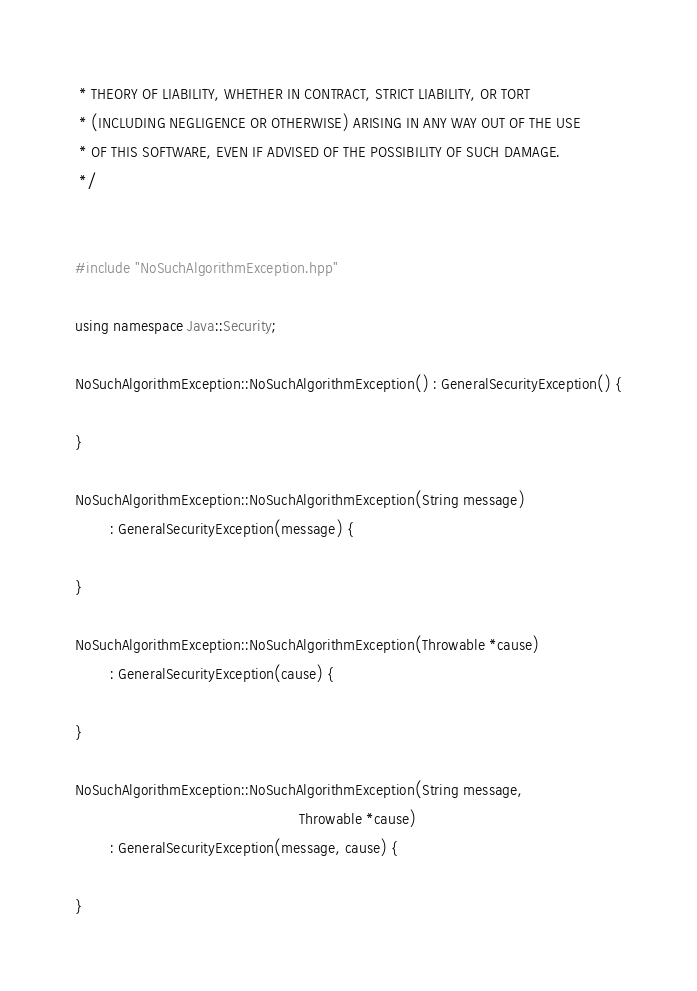Convert code to text. <code><loc_0><loc_0><loc_500><loc_500><_C++_> * THEORY OF LIABILITY, WHETHER IN CONTRACT, STRICT LIABILITY, OR TORT
 * (INCLUDING NEGLIGENCE OR OTHERWISE) ARISING IN ANY WAY OUT OF THE USE
 * OF THIS SOFTWARE, EVEN IF ADVISED OF THE POSSIBILITY OF SUCH DAMAGE.
 */


#include "NoSuchAlgorithmException.hpp"

using namespace Java::Security;

NoSuchAlgorithmException::NoSuchAlgorithmException() : GeneralSecurityException() {

}

NoSuchAlgorithmException::NoSuchAlgorithmException(String message)
        : GeneralSecurityException(message) {

}

NoSuchAlgorithmException::NoSuchAlgorithmException(Throwable *cause)
        : GeneralSecurityException(cause) {

}

NoSuchAlgorithmException::NoSuchAlgorithmException(String message,
                                                   Throwable *cause)
        : GeneralSecurityException(message, cause) {

}
</code> 